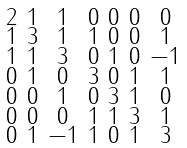Convert formula to latex. <formula><loc_0><loc_0><loc_500><loc_500>\begin{smallmatrix} 2 & 1 & 1 & 0 & 0 & 0 & 0 \\ 1 & 3 & 1 & 1 & 0 & 0 & 1 \\ 1 & 1 & 3 & 0 & 1 & 0 & - 1 \\ 0 & 1 & 0 & 3 & 0 & 1 & 1 \\ 0 & 0 & 1 & 0 & 3 & 1 & 0 \\ 0 & 0 & 0 & 1 & 1 & 3 & 1 \\ 0 & 1 & - 1 & 1 & 0 & 1 & 3 \end{smallmatrix}</formula> 